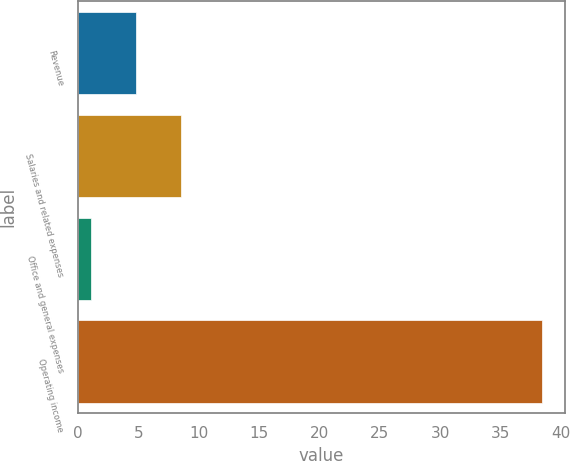<chart> <loc_0><loc_0><loc_500><loc_500><bar_chart><fcel>Revenue<fcel>Salaries and related expenses<fcel>Office and general expenses<fcel>Operating income<nl><fcel>4.83<fcel>8.56<fcel>1.1<fcel>38.4<nl></chart> 